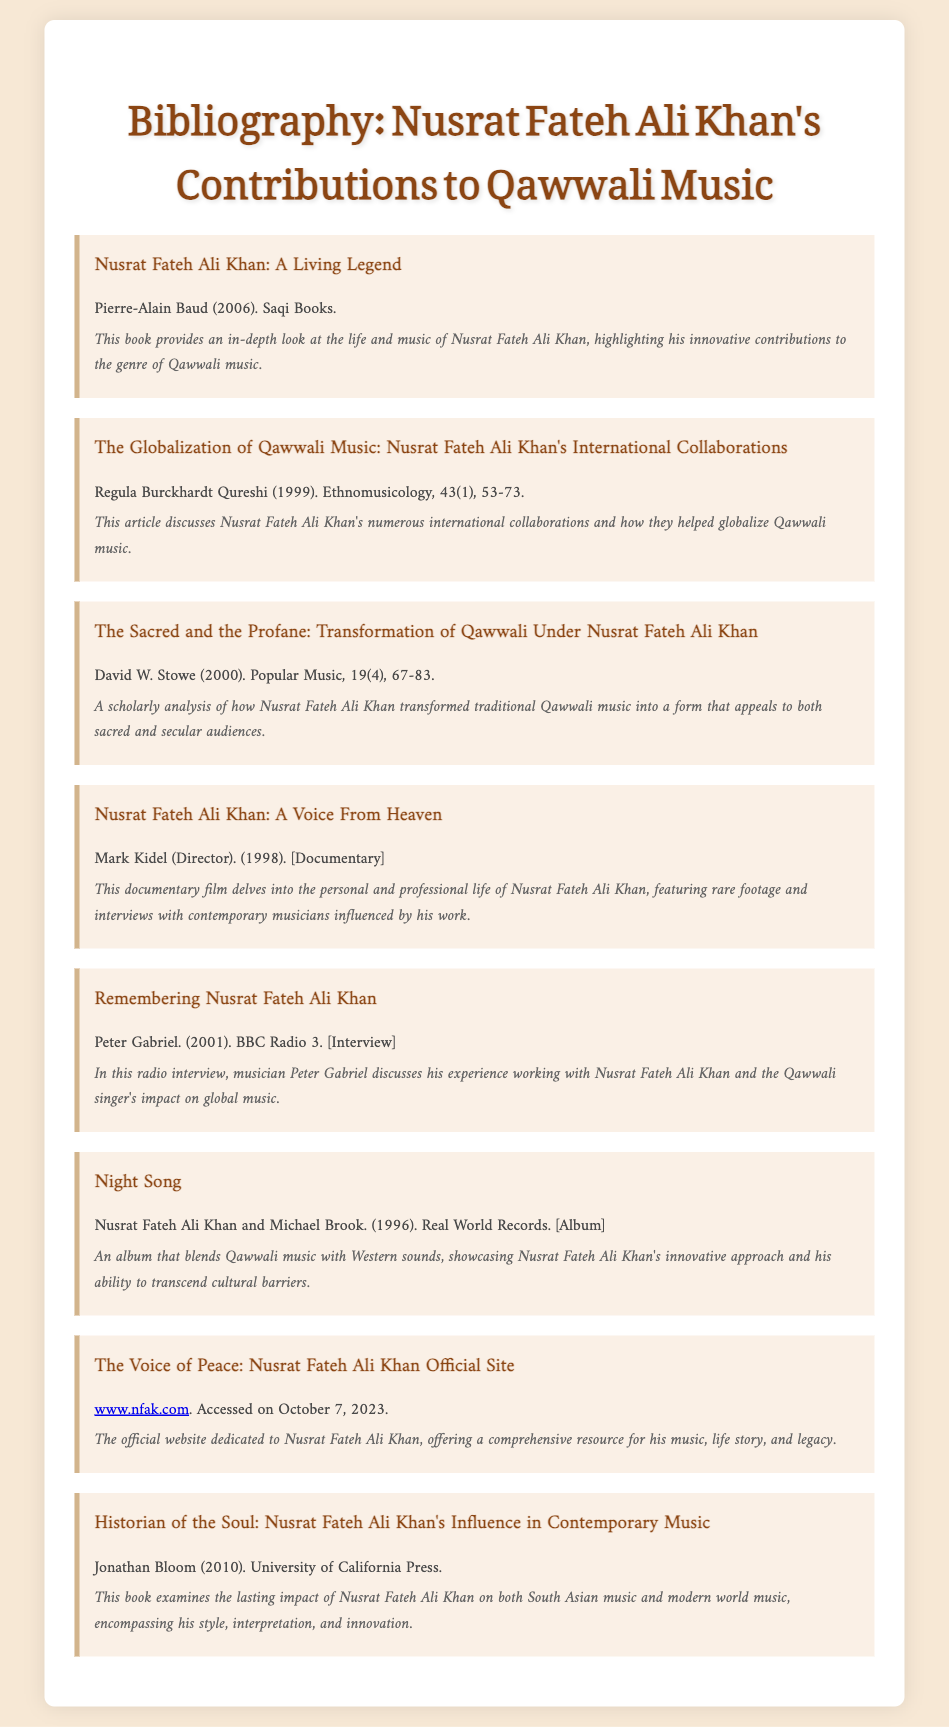What is the title of Pierre-Alain Baud's book? The title is provided as the first bibliography item in the document.
Answer: Nusrat Fateh Ali Khan: A Living Legend Who is the author of the article discussing international collaborations? The article is attributed to Regula Burckhardt Qureshi in the second bibliography item.
Answer: Regula Burckhardt Qureshi What year was "Nusrat Fateh Ali Khan: A Voice From Heaven" documentary released? The release date of this documentary can be found in the fourth bibliography item.
Answer: 1998 How many years after 1999 was the article on the transformation of Qawwali published? The publication date is in the document, requiring simple subtraction for the answer.
Answer: 1 What is the agency that featured Peter Gabriel's interview? The document lists BBC Radio 3 as the platform for the interview.
Answer: BBC Radio 3 What is the main focus of Jonathan Bloom's book? The summary in the bibliography mentions the impact of Nusrat Fateh Ali Khan on music.
Answer: Contemporary Music Which album involves collaboration between Nusrat Fateh Ali Khan and Michael Brook? The album title is listed in the document under the sixth bibliography item.
Answer: Night Song What type of document is "Remembering Nusrat Fateh Ali Khan"? The bibliographic item specifies the format of the document.
Answer: Interview 